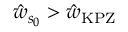Convert formula to latex. <formula><loc_0><loc_0><loc_500><loc_500>\hat { w } _ { s _ { 0 } } > \hat { w } _ { K P Z }</formula> 